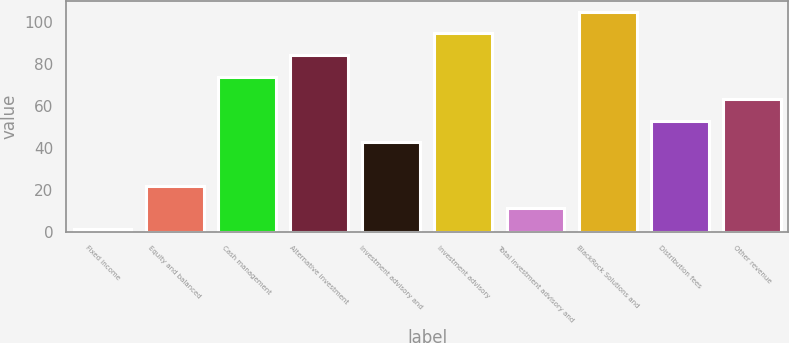<chart> <loc_0><loc_0><loc_500><loc_500><bar_chart><fcel>Fixed income<fcel>Equity and balanced<fcel>Cash management<fcel>Alternative investment<fcel>Investment advisory and<fcel>Investment advisory<fcel>Total investment advisory and<fcel>BlackRock Solutions and<fcel>Distribution fees<fcel>Other revenue<nl><fcel>1<fcel>21.8<fcel>73.8<fcel>84.2<fcel>42.6<fcel>94.6<fcel>11.4<fcel>105<fcel>53<fcel>63.4<nl></chart> 